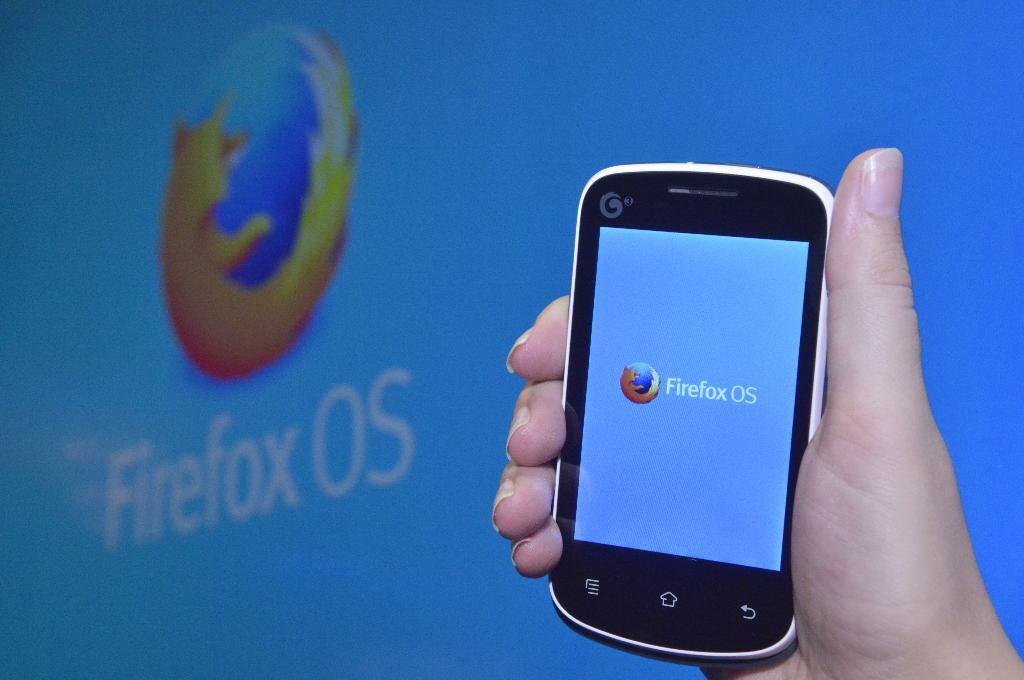<image>
Render a clear and concise summary of the photo. A hand-held phone displays the logo of Firefox OS. 